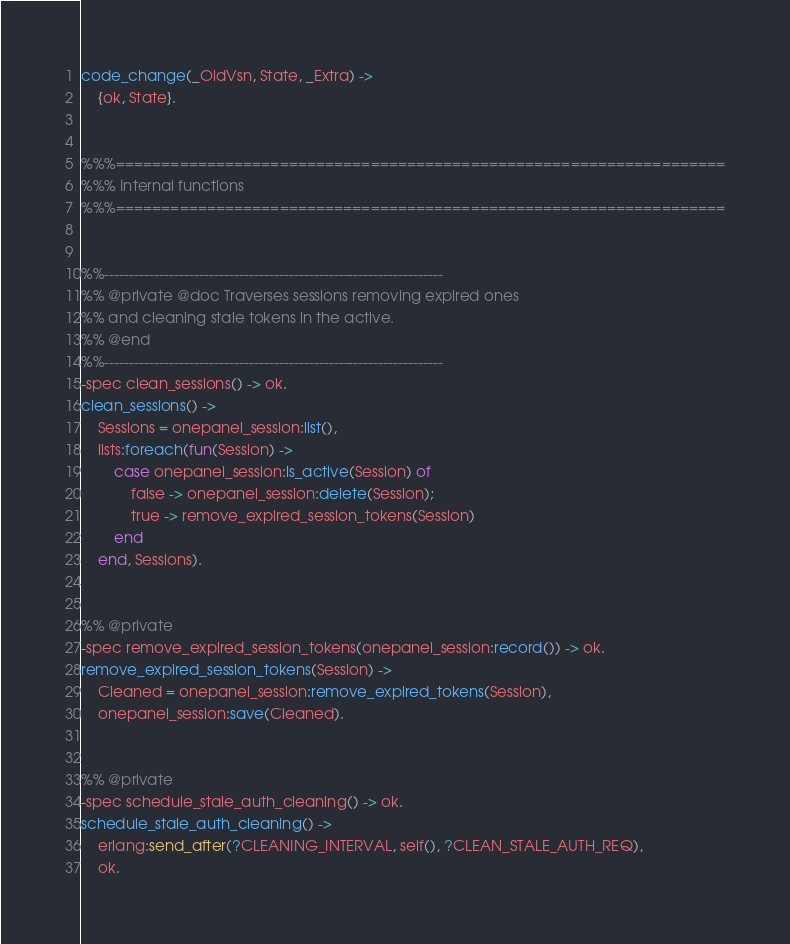Convert code to text. <code><loc_0><loc_0><loc_500><loc_500><_Erlang_>code_change(_OldVsn, State, _Extra) ->
    {ok, State}.


%%%===================================================================
%%% Internal functions
%%%===================================================================


%%--------------------------------------------------------------------
%% @private @doc Traverses sessions removing expired ones
%% and cleaning stale tokens in the active.
%% @end
%%--------------------------------------------------------------------
-spec clean_sessions() -> ok.
clean_sessions() ->
    Sessions = onepanel_session:list(),
    lists:foreach(fun(Session) ->
        case onepanel_session:is_active(Session) of
            false -> onepanel_session:delete(Session);
            true -> remove_expired_session_tokens(Session)
        end
    end, Sessions).


%% @private
-spec remove_expired_session_tokens(onepanel_session:record()) -> ok.
remove_expired_session_tokens(Session) ->
    Cleaned = onepanel_session:remove_expired_tokens(Session),
    onepanel_session:save(Cleaned).


%% @private
-spec schedule_stale_auth_cleaning() -> ok.
schedule_stale_auth_cleaning() ->
    erlang:send_after(?CLEANING_INTERVAL, self(), ?CLEAN_STALE_AUTH_REQ),
    ok.
</code> 